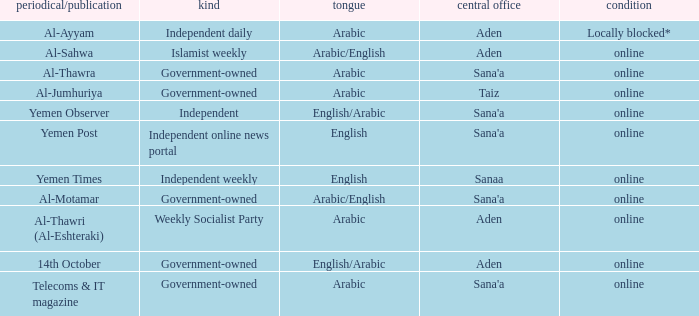What is Status, when Newspaper/Magazine is Al-Thawra? Online. 